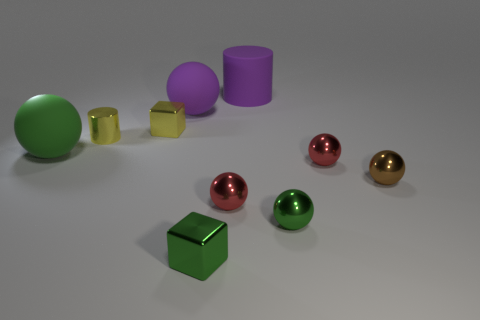What number of tiny cylinders are in front of the big purple cylinder that is right of the block right of the yellow shiny block?
Your answer should be compact. 1. There is a tiny yellow thing that is right of the tiny metal cylinder; what is its shape?
Your answer should be very brief. Cube. How many other things are there of the same material as the large purple ball?
Keep it short and to the point. 2. Does the large rubber cylinder have the same color as the metallic cylinder?
Give a very brief answer. No. Is the number of red metal spheres that are in front of the tiny brown sphere less than the number of rubber cylinders that are to the left of the green rubber thing?
Your answer should be very brief. No. There is another matte object that is the same shape as the big green rubber thing; what color is it?
Your answer should be compact. Purple. There is a cube that is behind the green metallic block; does it have the same size as the big green rubber ball?
Provide a short and direct response. No. Are there fewer yellow cylinders on the left side of the yellow metallic cylinder than tiny blocks?
Ensure brevity in your answer.  Yes. Are there any other things that are the same size as the yellow metallic cube?
Give a very brief answer. Yes. There is a cylinder in front of the big matte ball that is on the right side of the yellow cylinder; what size is it?
Give a very brief answer. Small. 